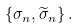<formula> <loc_0><loc_0><loc_500><loc_500>\left \{ \sigma _ { n } , \widetilde { \sigma } _ { n } \right \} .</formula> 